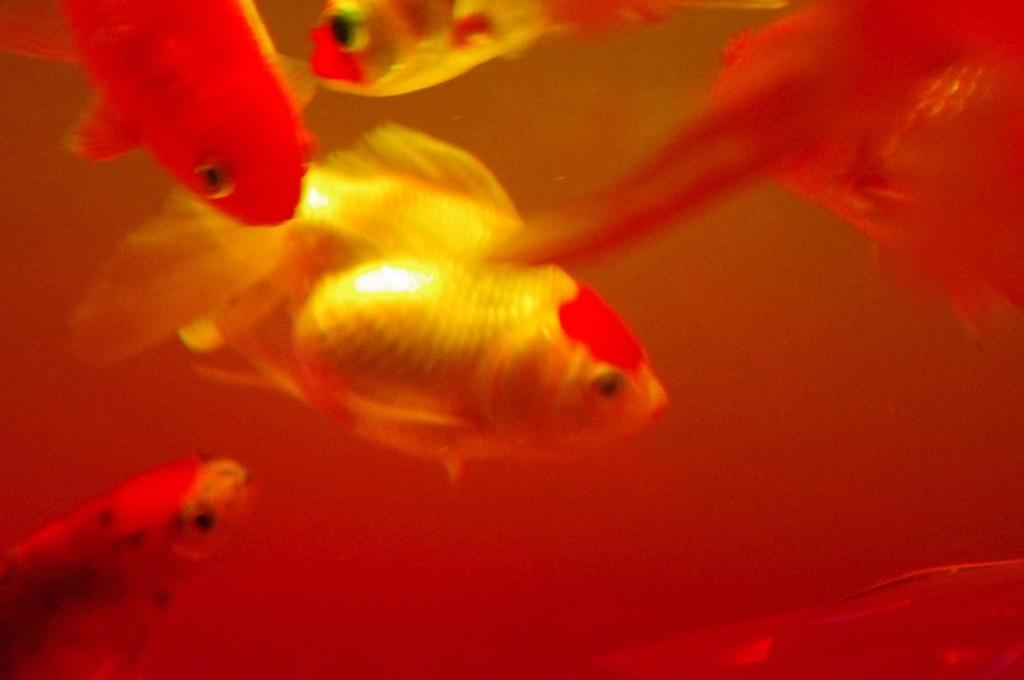What is the main subject of the image? The main subject of the image is many fish. Can you describe the appearance of the fish? The fish are orange and yellow in color. What type of protest is taking place in the image? There is no protest present in the image; it features many fish that are orange and yellow in color. What type of tent can be seen in the image? There is no tent present in the image; it features many fish that are orange and yellow in color. 